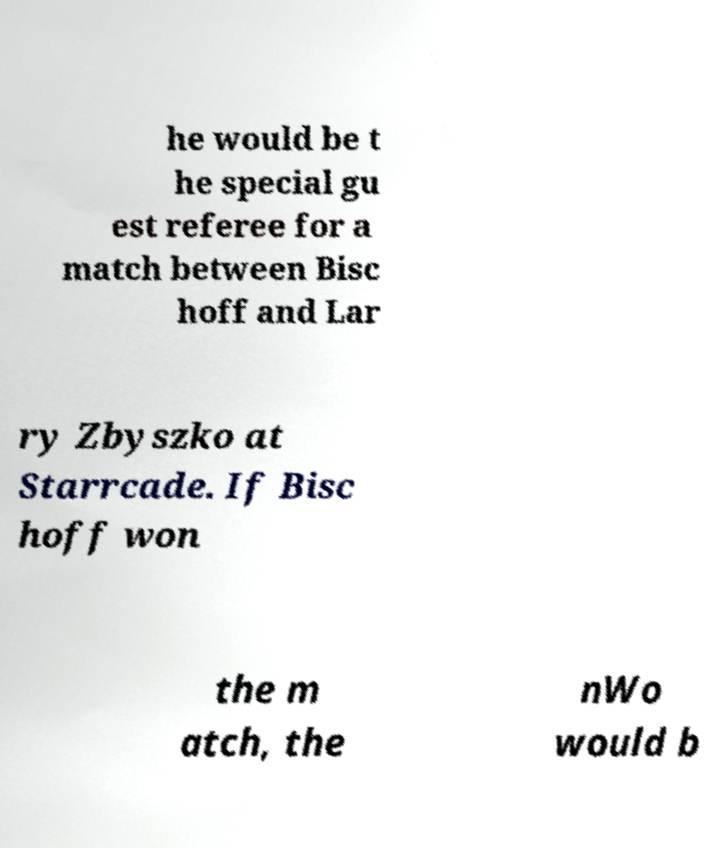I need the written content from this picture converted into text. Can you do that? he would be t he special gu est referee for a match between Bisc hoff and Lar ry Zbyszko at Starrcade. If Bisc hoff won the m atch, the nWo would b 